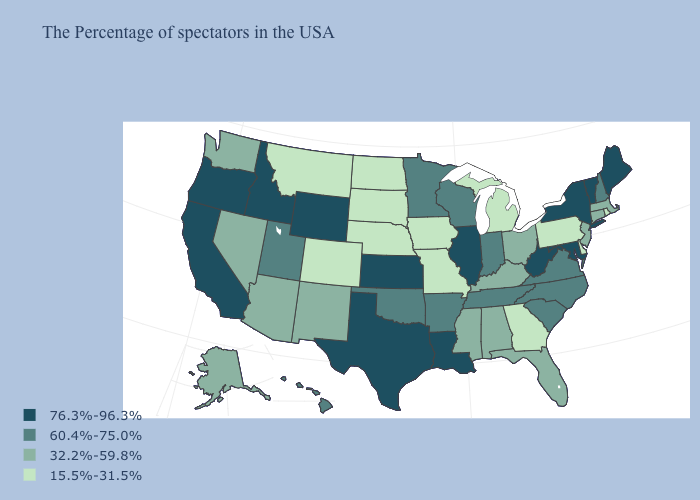Which states have the lowest value in the West?
Answer briefly. Colorado, Montana. What is the value of Delaware?
Concise answer only. 15.5%-31.5%. What is the highest value in the South ?
Answer briefly. 76.3%-96.3%. What is the value of South Carolina?
Short answer required. 60.4%-75.0%. Which states hav the highest value in the West?
Answer briefly. Wyoming, Idaho, California, Oregon. What is the value of Hawaii?
Concise answer only. 60.4%-75.0%. Among the states that border Arizona , does Colorado have the lowest value?
Keep it brief. Yes. Name the states that have a value in the range 32.2%-59.8%?
Keep it brief. Massachusetts, Connecticut, New Jersey, Ohio, Florida, Kentucky, Alabama, Mississippi, New Mexico, Arizona, Nevada, Washington, Alaska. Which states have the lowest value in the USA?
Give a very brief answer. Rhode Island, Delaware, Pennsylvania, Georgia, Michigan, Missouri, Iowa, Nebraska, South Dakota, North Dakota, Colorado, Montana. Name the states that have a value in the range 76.3%-96.3%?
Write a very short answer. Maine, Vermont, New York, Maryland, West Virginia, Illinois, Louisiana, Kansas, Texas, Wyoming, Idaho, California, Oregon. Does Wyoming have the same value as Illinois?
Concise answer only. Yes. What is the highest value in the USA?
Write a very short answer. 76.3%-96.3%. Among the states that border Maryland , does Virginia have the lowest value?
Answer briefly. No. Name the states that have a value in the range 32.2%-59.8%?
Keep it brief. Massachusetts, Connecticut, New Jersey, Ohio, Florida, Kentucky, Alabama, Mississippi, New Mexico, Arizona, Nevada, Washington, Alaska. 